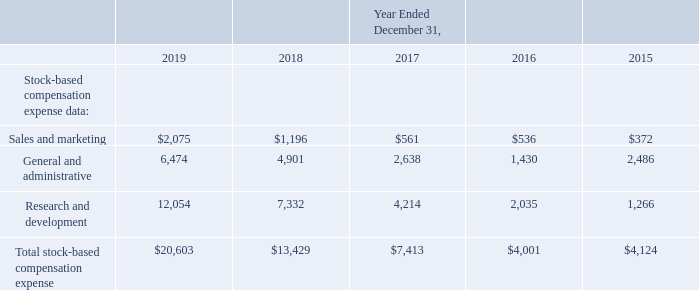ITEM 6. SELECTED FINANCIAL DATA
The selected consolidated statements of operations data for the years ended December 31, 2019, 2018 and 2017 and the selected consolidated balance sheet data as of December 31, 2019 and 2018 are derived from our audited consolidated financial statements included elsewhere in this Annual Report. The selected consolidated statements of operations data for the years ended December 31, 2016 and 2015 and the selected consolidated balance sheet data as of December 31, 2017, 2016 and 2015 are derived from our audited consolidated financial statements not included in this Annual Report. Our historical results are not necessarily indicative of the results to be expected in the future. The selected financial data should be read together with Item 7. "Management’s Discussion and Analysis of Financial Condition and Results of Operations" and in conjunction with our consolidated financial statements, related notes, and other financial information included elsewhere in this Annual Report. The following tables set forth our selected consolidated financial and other data for the years ended and as of December 31, 2019, 2018, 2017, 2016 and 2015 (in thousands, except share and per share data).
Information about prior period acquisitions that may affect the comparability of the selected financial information presented below is included in Item 1. Business. Information about the $28.0 million expense recorded in general and administrative expense in 2018, which relates to the agreement reached to settle the legal matter alleging violations of the Telephone Consumer Protection Act, or TCPA, and may affect the comparability of the selected financial information presented below, is disclosed in Item 3. “Legal Proceedings.” Information about the $1.7 million of interest recorded within interest income and the $6.9 million of gain recorded within other income, net, in 2019, which relates to promissory note proceeds received from one of our hardware suppliers and proceeds from an acquired promissory note, and may affect the comparability of the selected financial information presented below, is disclosed in Item 7. "Management’s Discussion and Analysis of Financial Condition and Results of Operations."
Certain previously reported amounts in the consolidated statements of operations for the years ended December 31, 2018, 2017, 2016 and 2015 have been reclassified to conform to our current presentation to reflect interest income as a separate line item, which was previously included in other income, net.
What years does the table provide data for sales and marketing? 2019, 2018, 2017, 2016, 2015. What was the amount of sales and marketing in 2018?
Answer scale should be: thousand. $1,196. What was the amount of research and development in 2018?
Answer scale should be: thousand. 7,332. How many years did the amount of general and administrative exceed $5,000 thousand? 2019
Answer: 1. What was the change in the amount of research and development between 2018 and 2019?
Answer scale should be: thousand. 12,054-7,332
Answer: 4722. What was the percentage change in the Total stock-based compensation expense between 2018 and 2019?
Answer scale should be: percent. (20,603-13,429)/13,429
Answer: 53.42. 